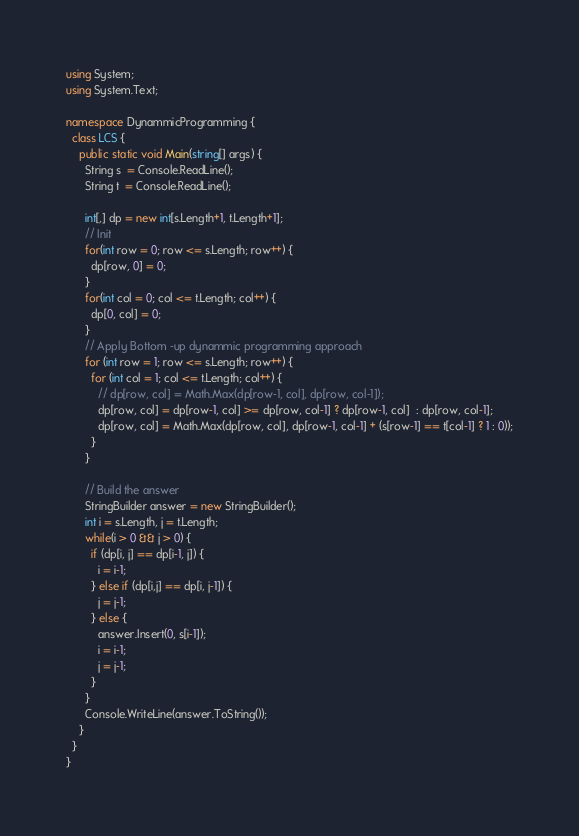Convert code to text. <code><loc_0><loc_0><loc_500><loc_500><_C#_>using System;
using System.Text;

namespace DynammicProgramming {
  class LCS {
    public static void Main(string[] args) {
      String s  = Console.ReadLine();
      String t  = Console.ReadLine();

      int[,] dp = new int[s.Length+1, t.Length+1];
      // Init
      for(int row = 0; row <= s.Length; row++) {
        dp[row, 0] = 0;
      }
      for(int col = 0; col <= t.Length; col++) {
        dp[0, col] = 0;
      }
      // Apply Bottom -up dynammic programming approach
      for (int row = 1; row <= s.Length; row++) {
        for (int col = 1; col <= t.Length; col++) {
          // dp[row, col] = Math.Max(dp[row-1, col], dp[row, col-1]);
          dp[row, col] = dp[row-1, col] >= dp[row, col-1] ? dp[row-1, col]  : dp[row, col-1];
          dp[row, col] = Math.Max(dp[row, col], dp[row-1, col-1] + (s[row-1] == t[col-1] ? 1 : 0));
        }
      }

      // Build the answer 
      StringBuilder answer = new StringBuilder();
      int i = s.Length, j = t.Length;
      while(i > 0 && j > 0) {
        if (dp[i, j] == dp[i-1, j]) {
          i = i-1;
        } else if (dp[i,j] == dp[i, j-1]) {
          j = j-1;
        } else {
          answer.Insert(0, s[i-1]);
          i = i-1;
          j = j-1;
        }
      }
      Console.WriteLine(answer.ToString());
    }
  }
}</code> 